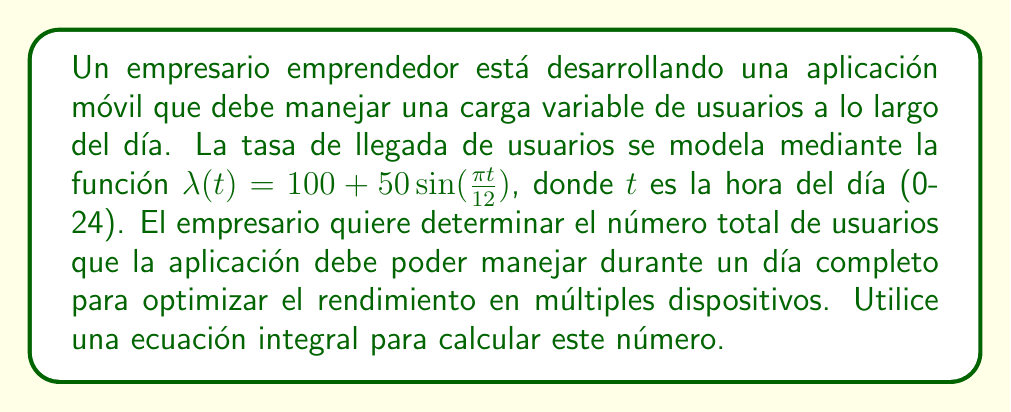Teach me how to tackle this problem. Para resolver este problema, seguiremos estos pasos:

1) La función $\lambda(t) = 100 + 50\sin(\frac{\pi t}{12})$ representa la tasa de llegada de usuarios por hora.

2) Para obtener el número total de usuarios durante un día completo, necesitamos integrar esta función sobre el intervalo de 0 a 24 horas:

   $$N = \int_0^{24} \lambda(t) dt$$

3) Sustituyendo la función $\lambda(t)$:

   $$N = \int_0^{24} (100 + 50\sin(\frac{\pi t}{12})) dt$$

4) Separamos la integral:

   $$N = \int_0^{24} 100 dt + \int_0^{24} 50\sin(\frac{\pi t}{12}) dt$$

5) Resolvemos la primera parte:

   $$\int_0^{24} 100 dt = 100t \Big|_0^{24} = 2400$$

6) Para la segunda parte, usamos la sustitución $u = \frac{\pi t}{12}$, $du = \frac{\pi}{12} dt$:

   $$\int_0^{24} 50\sin(\frac{\pi t}{12}) dt = \frac{600}{\pi} \int_0^{2\pi} \sin(u) du$$

7) Resolvemos esta integral:

   $$\frac{600}{\pi} [-\cos(u)]_0^{2\pi} = \frac{600}{\pi} [(-\cos(2\pi)) - (-\cos(0))] = 0$$

8) Sumamos los resultados de los pasos 5 y 7:

   $$N = 2400 + 0 = 2400$$

Por lo tanto, la aplicación debe poder manejar 2400 usuarios durante un día completo para optimizar el rendimiento en múltiples dispositivos.
Answer: 2400 usuarios 